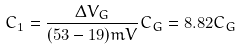Convert formula to latex. <formula><loc_0><loc_0><loc_500><loc_500>C _ { 1 } = \frac { \Delta V _ { G } } { ( 5 3 - 1 9 ) m V } C _ { G } = 8 . 8 2 C _ { G }</formula> 